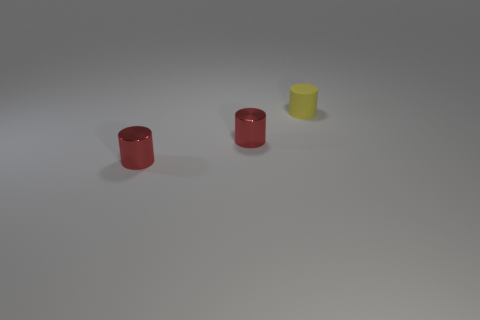What might be the use of these objects? These objects appear to be simple geometric shapes often used for educational or decorative purposes. They could be part of a children's toy set, designed for learning colors and shapes, or they could be modern art pieces. 